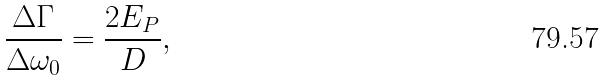Convert formula to latex. <formula><loc_0><loc_0><loc_500><loc_500>\frac { \Delta \Gamma } { \Delta \omega _ { 0 } } = \frac { 2 E _ { P } } { D } ,</formula> 